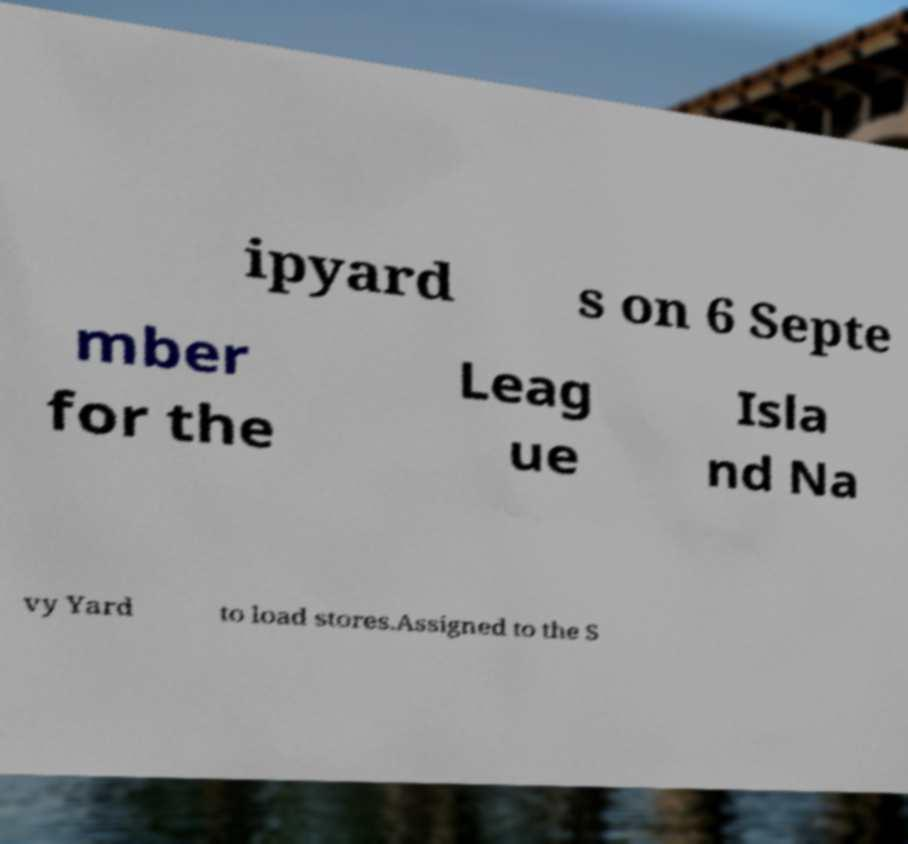There's text embedded in this image that I need extracted. Can you transcribe it verbatim? ipyard s on 6 Septe mber for the Leag ue Isla nd Na vy Yard to load stores.Assigned to the S 